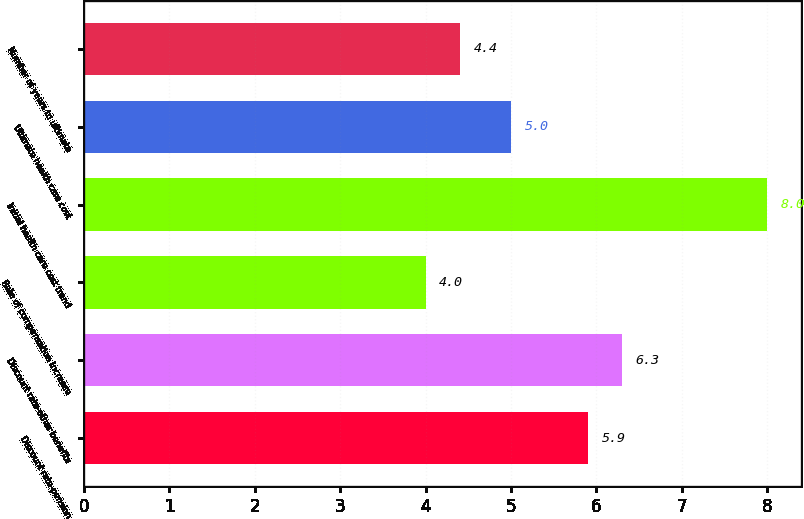<chart> <loc_0><loc_0><loc_500><loc_500><bar_chart><fcel>Discount rate-pension<fcel>Discount rate-other benefits<fcel>Rate of compensation increase<fcel>Initial health care cost trend<fcel>Ultimate health care cost<fcel>Number of years to ultimate<nl><fcel>5.9<fcel>6.3<fcel>4<fcel>8<fcel>5<fcel>4.4<nl></chart> 